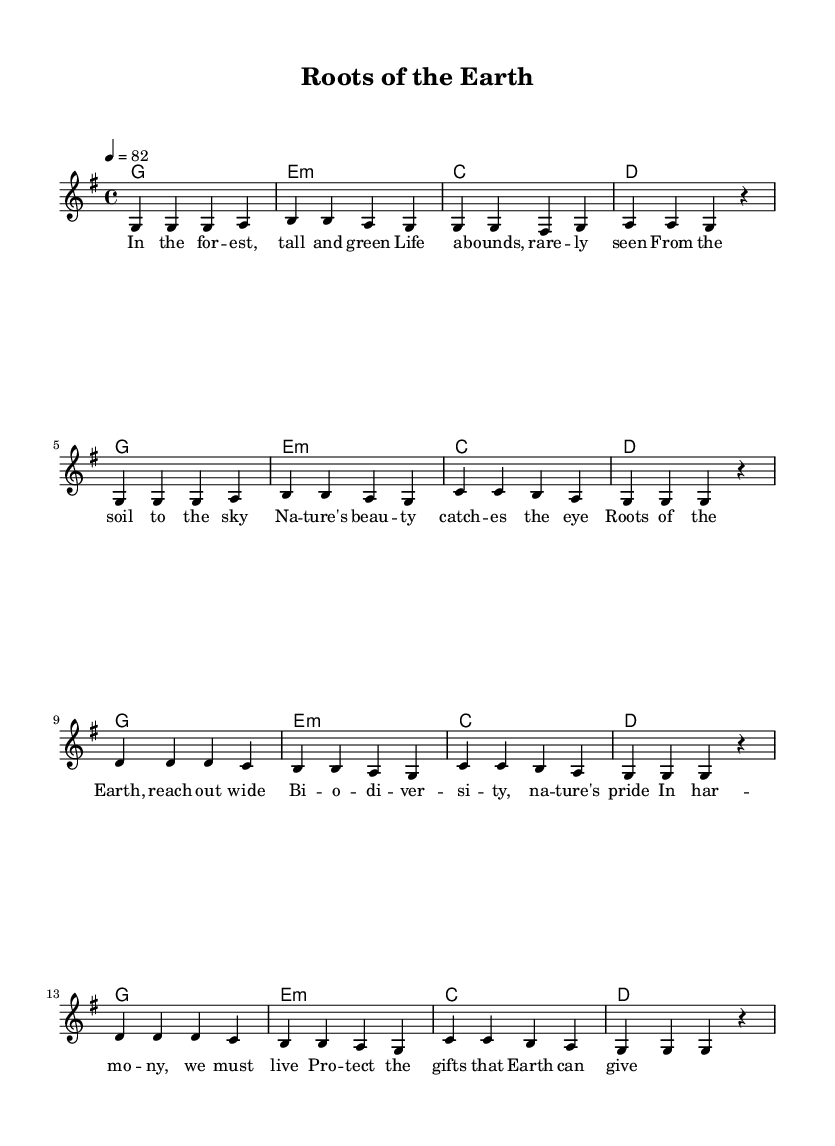What is the key signature of this music? The key signature indicates that this piece is in G major, which has one sharp. You can see the F# indicated in the key signature at the beginning of the music.
Answer: G major What is the time signature of this music? The time signature is 4/4, which means there are four beats in each measure, and the quarter note receives one beat. This is visible in the time signature notation at the beginning of the sheet music.
Answer: 4/4 What is the tempo marking of the piece? The tempo marking indicates that the piece should be played at a speed of 82 beats per minute. This is provided in the tempo indication at the beginning of the music section.
Answer: 82 How many measures are in the chorus section? By counting the groups of four beats (four notes per beat) in the chorus, there are a total of 8 measures in that section, as denoted by the repeated structure of the lines.
Answer: 8 What is the primary theme of the lyrics in this song? The lyrics of this song focus on the beauty of nature and the importance of biodiversity, as conveyed through phrases about forests, life, and protecting Earth's gifts. This is inferred from both the verses and the chorus, which revolve around these topics.
Answer: Nature and biodiversity What type of chords are predominantly used in this piece? The predominant chords in this piece are major chords, along with a minor chord (the E minor chord), making it fit the Major-Minor harmony commonly used in Reggae music. The chord names above the staff indicate G, E minor, C, and D.
Answer: Major and minor chords How does the song reflect typical Reggae musical characteristics? The song reflects Reggae characteristics through its laid-back tempo and the rhythmic placement of accents in the melody and harmony, creating an offbeat feel often associated with Reggae music. This genre typically emphasizes the second and fourth beats, seen in the rhythmic structure provided.
Answer: Laid-back rhythm 